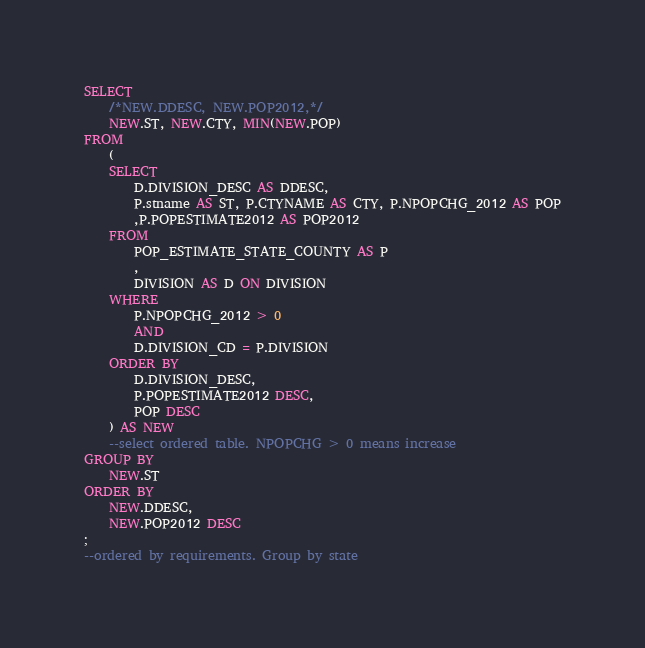Convert code to text. <code><loc_0><loc_0><loc_500><loc_500><_SQL_>SELECT 
	/*NEW.DDESC, NEW.POP2012,*/
	NEW.ST, NEW.CTY, MIN(NEW.POP)
FROM
	(
	SELECT
		D.DIVISION_DESC AS DDESC, 
		P.stname AS ST, P.CTYNAME AS CTY, P.NPOPCHG_2012 AS POP
		,P.POPESTIMATE2012 AS POP2012
	FROM
		POP_ESTIMATE_STATE_COUNTY AS P
		,
		DIVISION AS D ON DIVISION
	WHERE
		P.NPOPCHG_2012 > 0
		AND 
		D.DIVISION_CD = P.DIVISION
	ORDER BY
		D.DIVISION_DESC,
		P.POPESTIMATE2012 DESC,
		POP DESC
	) AS NEW
	--select ordered table. NPOPCHG > 0 means increase
GROUP BY
	NEW.ST
ORDER BY
	NEW.DDESC,
	NEW.POP2012 DESC
;
--ordered by requirements. Group by state

</code> 